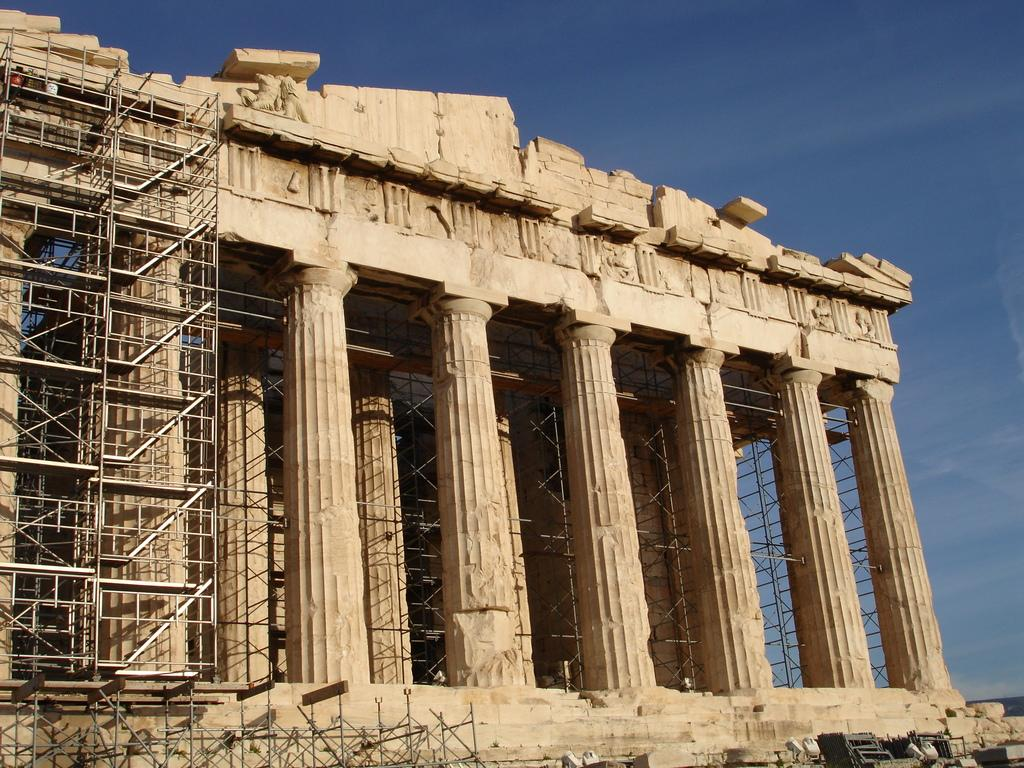What type of structure is present in the image? There is a building in the image. Are there any architectural features visible in the image? Yes, there are steps in the image. What can be seen in the background of the image? The sky is visible in the background of the image. What is the condition of the sky in the image? There are clouds in the sky. Can you tell me how many pages of prose are visible in the image? There is no prose present in the image; it features a building, steps, and a cloudy sky. Is there a beggar sitting on the steps in the image? There is no beggar present in the image; it only shows a building, steps, and a cloudy sky. 